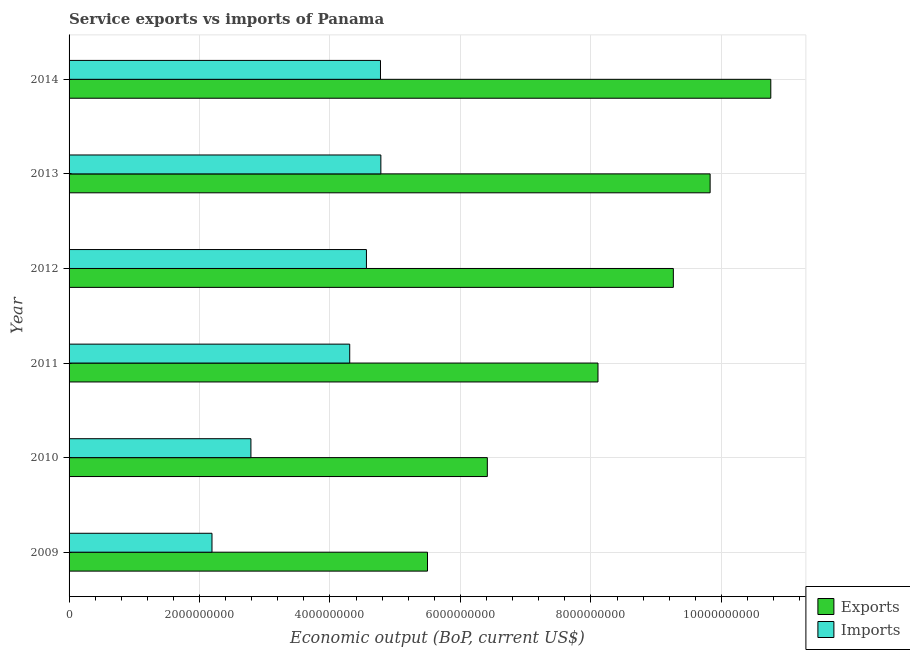Are the number of bars per tick equal to the number of legend labels?
Provide a short and direct response. Yes. Are the number of bars on each tick of the Y-axis equal?
Your response must be concise. Yes. How many bars are there on the 3rd tick from the top?
Your response must be concise. 2. How many bars are there on the 4th tick from the bottom?
Make the answer very short. 2. What is the amount of service exports in 2013?
Your answer should be very brief. 9.83e+09. Across all years, what is the maximum amount of service imports?
Give a very brief answer. 4.78e+09. Across all years, what is the minimum amount of service imports?
Make the answer very short. 2.19e+09. In which year was the amount of service exports minimum?
Make the answer very short. 2009. What is the total amount of service imports in the graph?
Give a very brief answer. 2.34e+1. What is the difference between the amount of service imports in 2011 and that in 2012?
Provide a short and direct response. -2.56e+08. What is the difference between the amount of service imports in 2014 and the amount of service exports in 2013?
Offer a terse response. -5.05e+09. What is the average amount of service imports per year?
Provide a succinct answer. 3.90e+09. In the year 2012, what is the difference between the amount of service imports and amount of service exports?
Give a very brief answer. -4.70e+09. In how many years, is the amount of service exports greater than 4800000000 US$?
Offer a terse response. 6. What is the ratio of the amount of service exports in 2010 to that in 2014?
Ensure brevity in your answer.  0.6. Is the difference between the amount of service imports in 2009 and 2010 greater than the difference between the amount of service exports in 2009 and 2010?
Give a very brief answer. Yes. What is the difference between the highest and the second highest amount of service exports?
Keep it short and to the point. 9.30e+08. What is the difference between the highest and the lowest amount of service exports?
Your answer should be compact. 5.26e+09. Is the sum of the amount of service exports in 2013 and 2014 greater than the maximum amount of service imports across all years?
Make the answer very short. Yes. What does the 2nd bar from the top in 2011 represents?
Make the answer very short. Exports. What does the 2nd bar from the bottom in 2012 represents?
Your answer should be very brief. Imports. How many bars are there?
Offer a terse response. 12. Are all the bars in the graph horizontal?
Offer a very short reply. Yes. What is the difference between two consecutive major ticks on the X-axis?
Offer a very short reply. 2.00e+09. Are the values on the major ticks of X-axis written in scientific E-notation?
Keep it short and to the point. No. Does the graph contain any zero values?
Your answer should be very brief. No. What is the title of the graph?
Offer a terse response. Service exports vs imports of Panama. Does "Overweight" appear as one of the legend labels in the graph?
Your answer should be compact. No. What is the label or title of the X-axis?
Ensure brevity in your answer.  Economic output (BoP, current US$). What is the Economic output (BoP, current US$) of Exports in 2009?
Ensure brevity in your answer.  5.49e+09. What is the Economic output (BoP, current US$) in Imports in 2009?
Your answer should be compact. 2.19e+09. What is the Economic output (BoP, current US$) of Exports in 2010?
Keep it short and to the point. 6.41e+09. What is the Economic output (BoP, current US$) in Imports in 2010?
Offer a very short reply. 2.79e+09. What is the Economic output (BoP, current US$) in Exports in 2011?
Keep it short and to the point. 8.11e+09. What is the Economic output (BoP, current US$) in Imports in 2011?
Offer a very short reply. 4.30e+09. What is the Economic output (BoP, current US$) of Exports in 2012?
Your answer should be compact. 9.26e+09. What is the Economic output (BoP, current US$) in Imports in 2012?
Offer a terse response. 4.56e+09. What is the Economic output (BoP, current US$) in Exports in 2013?
Offer a terse response. 9.83e+09. What is the Economic output (BoP, current US$) of Imports in 2013?
Offer a very short reply. 4.78e+09. What is the Economic output (BoP, current US$) in Exports in 2014?
Keep it short and to the point. 1.08e+1. What is the Economic output (BoP, current US$) in Imports in 2014?
Give a very brief answer. 4.77e+09. Across all years, what is the maximum Economic output (BoP, current US$) of Exports?
Give a very brief answer. 1.08e+1. Across all years, what is the maximum Economic output (BoP, current US$) in Imports?
Keep it short and to the point. 4.78e+09. Across all years, what is the minimum Economic output (BoP, current US$) in Exports?
Give a very brief answer. 5.49e+09. Across all years, what is the minimum Economic output (BoP, current US$) of Imports?
Keep it short and to the point. 2.19e+09. What is the total Economic output (BoP, current US$) in Exports in the graph?
Keep it short and to the point. 4.99e+1. What is the total Economic output (BoP, current US$) of Imports in the graph?
Your answer should be very brief. 2.34e+1. What is the difference between the Economic output (BoP, current US$) of Exports in 2009 and that in 2010?
Provide a short and direct response. -9.17e+08. What is the difference between the Economic output (BoP, current US$) in Imports in 2009 and that in 2010?
Provide a short and direct response. -5.97e+08. What is the difference between the Economic output (BoP, current US$) in Exports in 2009 and that in 2011?
Offer a terse response. -2.61e+09. What is the difference between the Economic output (BoP, current US$) in Imports in 2009 and that in 2011?
Provide a short and direct response. -2.11e+09. What is the difference between the Economic output (BoP, current US$) in Exports in 2009 and that in 2012?
Your answer should be compact. -3.77e+09. What is the difference between the Economic output (BoP, current US$) in Imports in 2009 and that in 2012?
Provide a succinct answer. -2.37e+09. What is the difference between the Economic output (BoP, current US$) of Exports in 2009 and that in 2013?
Make the answer very short. -4.33e+09. What is the difference between the Economic output (BoP, current US$) of Imports in 2009 and that in 2013?
Ensure brevity in your answer.  -2.59e+09. What is the difference between the Economic output (BoP, current US$) in Exports in 2009 and that in 2014?
Give a very brief answer. -5.26e+09. What is the difference between the Economic output (BoP, current US$) in Imports in 2009 and that in 2014?
Make the answer very short. -2.58e+09. What is the difference between the Economic output (BoP, current US$) of Exports in 2010 and that in 2011?
Your answer should be very brief. -1.70e+09. What is the difference between the Economic output (BoP, current US$) of Imports in 2010 and that in 2011?
Provide a short and direct response. -1.51e+09. What is the difference between the Economic output (BoP, current US$) of Exports in 2010 and that in 2012?
Provide a succinct answer. -2.85e+09. What is the difference between the Economic output (BoP, current US$) of Imports in 2010 and that in 2012?
Your response must be concise. -1.77e+09. What is the difference between the Economic output (BoP, current US$) of Exports in 2010 and that in 2013?
Provide a succinct answer. -3.42e+09. What is the difference between the Economic output (BoP, current US$) in Imports in 2010 and that in 2013?
Provide a succinct answer. -1.99e+09. What is the difference between the Economic output (BoP, current US$) in Exports in 2010 and that in 2014?
Offer a terse response. -4.35e+09. What is the difference between the Economic output (BoP, current US$) in Imports in 2010 and that in 2014?
Offer a terse response. -1.99e+09. What is the difference between the Economic output (BoP, current US$) of Exports in 2011 and that in 2012?
Give a very brief answer. -1.16e+09. What is the difference between the Economic output (BoP, current US$) of Imports in 2011 and that in 2012?
Your answer should be very brief. -2.56e+08. What is the difference between the Economic output (BoP, current US$) of Exports in 2011 and that in 2013?
Your response must be concise. -1.72e+09. What is the difference between the Economic output (BoP, current US$) of Imports in 2011 and that in 2013?
Provide a short and direct response. -4.77e+08. What is the difference between the Economic output (BoP, current US$) of Exports in 2011 and that in 2014?
Offer a terse response. -2.65e+09. What is the difference between the Economic output (BoP, current US$) in Imports in 2011 and that in 2014?
Keep it short and to the point. -4.72e+08. What is the difference between the Economic output (BoP, current US$) in Exports in 2012 and that in 2013?
Offer a very short reply. -5.64e+08. What is the difference between the Economic output (BoP, current US$) of Imports in 2012 and that in 2013?
Provide a succinct answer. -2.21e+08. What is the difference between the Economic output (BoP, current US$) of Exports in 2012 and that in 2014?
Offer a very short reply. -1.49e+09. What is the difference between the Economic output (BoP, current US$) in Imports in 2012 and that in 2014?
Offer a very short reply. -2.15e+08. What is the difference between the Economic output (BoP, current US$) of Exports in 2013 and that in 2014?
Make the answer very short. -9.30e+08. What is the difference between the Economic output (BoP, current US$) in Imports in 2013 and that in 2014?
Your answer should be very brief. 5.80e+06. What is the difference between the Economic output (BoP, current US$) of Exports in 2009 and the Economic output (BoP, current US$) of Imports in 2010?
Offer a terse response. 2.71e+09. What is the difference between the Economic output (BoP, current US$) of Exports in 2009 and the Economic output (BoP, current US$) of Imports in 2011?
Ensure brevity in your answer.  1.19e+09. What is the difference between the Economic output (BoP, current US$) in Exports in 2009 and the Economic output (BoP, current US$) in Imports in 2012?
Provide a short and direct response. 9.36e+08. What is the difference between the Economic output (BoP, current US$) of Exports in 2009 and the Economic output (BoP, current US$) of Imports in 2013?
Your answer should be compact. 7.15e+08. What is the difference between the Economic output (BoP, current US$) in Exports in 2009 and the Economic output (BoP, current US$) in Imports in 2014?
Make the answer very short. 7.21e+08. What is the difference between the Economic output (BoP, current US$) of Exports in 2010 and the Economic output (BoP, current US$) of Imports in 2011?
Your answer should be very brief. 2.11e+09. What is the difference between the Economic output (BoP, current US$) in Exports in 2010 and the Economic output (BoP, current US$) in Imports in 2012?
Keep it short and to the point. 1.85e+09. What is the difference between the Economic output (BoP, current US$) in Exports in 2010 and the Economic output (BoP, current US$) in Imports in 2013?
Keep it short and to the point. 1.63e+09. What is the difference between the Economic output (BoP, current US$) of Exports in 2010 and the Economic output (BoP, current US$) of Imports in 2014?
Provide a short and direct response. 1.64e+09. What is the difference between the Economic output (BoP, current US$) in Exports in 2011 and the Economic output (BoP, current US$) in Imports in 2012?
Your answer should be very brief. 3.55e+09. What is the difference between the Economic output (BoP, current US$) of Exports in 2011 and the Economic output (BoP, current US$) of Imports in 2013?
Ensure brevity in your answer.  3.33e+09. What is the difference between the Economic output (BoP, current US$) of Exports in 2011 and the Economic output (BoP, current US$) of Imports in 2014?
Keep it short and to the point. 3.33e+09. What is the difference between the Economic output (BoP, current US$) of Exports in 2012 and the Economic output (BoP, current US$) of Imports in 2013?
Your answer should be very brief. 4.48e+09. What is the difference between the Economic output (BoP, current US$) of Exports in 2012 and the Economic output (BoP, current US$) of Imports in 2014?
Make the answer very short. 4.49e+09. What is the difference between the Economic output (BoP, current US$) in Exports in 2013 and the Economic output (BoP, current US$) in Imports in 2014?
Your answer should be very brief. 5.05e+09. What is the average Economic output (BoP, current US$) of Exports per year?
Ensure brevity in your answer.  8.31e+09. What is the average Economic output (BoP, current US$) of Imports per year?
Make the answer very short. 3.90e+09. In the year 2009, what is the difference between the Economic output (BoP, current US$) in Exports and Economic output (BoP, current US$) in Imports?
Keep it short and to the point. 3.30e+09. In the year 2010, what is the difference between the Economic output (BoP, current US$) in Exports and Economic output (BoP, current US$) in Imports?
Provide a succinct answer. 3.62e+09. In the year 2011, what is the difference between the Economic output (BoP, current US$) in Exports and Economic output (BoP, current US$) in Imports?
Provide a short and direct response. 3.81e+09. In the year 2012, what is the difference between the Economic output (BoP, current US$) in Exports and Economic output (BoP, current US$) in Imports?
Give a very brief answer. 4.70e+09. In the year 2013, what is the difference between the Economic output (BoP, current US$) of Exports and Economic output (BoP, current US$) of Imports?
Ensure brevity in your answer.  5.05e+09. In the year 2014, what is the difference between the Economic output (BoP, current US$) in Exports and Economic output (BoP, current US$) in Imports?
Give a very brief answer. 5.98e+09. What is the ratio of the Economic output (BoP, current US$) of Exports in 2009 to that in 2010?
Your answer should be compact. 0.86. What is the ratio of the Economic output (BoP, current US$) of Imports in 2009 to that in 2010?
Keep it short and to the point. 0.79. What is the ratio of the Economic output (BoP, current US$) of Exports in 2009 to that in 2011?
Your answer should be very brief. 0.68. What is the ratio of the Economic output (BoP, current US$) of Imports in 2009 to that in 2011?
Provide a succinct answer. 0.51. What is the ratio of the Economic output (BoP, current US$) of Exports in 2009 to that in 2012?
Make the answer very short. 0.59. What is the ratio of the Economic output (BoP, current US$) in Imports in 2009 to that in 2012?
Your response must be concise. 0.48. What is the ratio of the Economic output (BoP, current US$) in Exports in 2009 to that in 2013?
Offer a terse response. 0.56. What is the ratio of the Economic output (BoP, current US$) of Imports in 2009 to that in 2013?
Your response must be concise. 0.46. What is the ratio of the Economic output (BoP, current US$) in Exports in 2009 to that in 2014?
Provide a succinct answer. 0.51. What is the ratio of the Economic output (BoP, current US$) in Imports in 2009 to that in 2014?
Keep it short and to the point. 0.46. What is the ratio of the Economic output (BoP, current US$) in Exports in 2010 to that in 2011?
Offer a terse response. 0.79. What is the ratio of the Economic output (BoP, current US$) in Imports in 2010 to that in 2011?
Offer a terse response. 0.65. What is the ratio of the Economic output (BoP, current US$) of Exports in 2010 to that in 2012?
Make the answer very short. 0.69. What is the ratio of the Economic output (BoP, current US$) in Imports in 2010 to that in 2012?
Provide a short and direct response. 0.61. What is the ratio of the Economic output (BoP, current US$) in Exports in 2010 to that in 2013?
Your answer should be very brief. 0.65. What is the ratio of the Economic output (BoP, current US$) in Imports in 2010 to that in 2013?
Ensure brevity in your answer.  0.58. What is the ratio of the Economic output (BoP, current US$) of Exports in 2010 to that in 2014?
Your answer should be compact. 0.6. What is the ratio of the Economic output (BoP, current US$) in Imports in 2010 to that in 2014?
Your answer should be very brief. 0.58. What is the ratio of the Economic output (BoP, current US$) of Exports in 2011 to that in 2012?
Your response must be concise. 0.88. What is the ratio of the Economic output (BoP, current US$) of Imports in 2011 to that in 2012?
Keep it short and to the point. 0.94. What is the ratio of the Economic output (BoP, current US$) of Exports in 2011 to that in 2013?
Provide a short and direct response. 0.83. What is the ratio of the Economic output (BoP, current US$) in Imports in 2011 to that in 2013?
Offer a very short reply. 0.9. What is the ratio of the Economic output (BoP, current US$) of Exports in 2011 to that in 2014?
Your answer should be compact. 0.75. What is the ratio of the Economic output (BoP, current US$) in Imports in 2011 to that in 2014?
Give a very brief answer. 0.9. What is the ratio of the Economic output (BoP, current US$) in Exports in 2012 to that in 2013?
Provide a short and direct response. 0.94. What is the ratio of the Economic output (BoP, current US$) of Imports in 2012 to that in 2013?
Your answer should be compact. 0.95. What is the ratio of the Economic output (BoP, current US$) in Exports in 2012 to that in 2014?
Your response must be concise. 0.86. What is the ratio of the Economic output (BoP, current US$) in Imports in 2012 to that in 2014?
Offer a terse response. 0.95. What is the ratio of the Economic output (BoP, current US$) of Exports in 2013 to that in 2014?
Offer a very short reply. 0.91. What is the difference between the highest and the second highest Economic output (BoP, current US$) in Exports?
Make the answer very short. 9.30e+08. What is the difference between the highest and the second highest Economic output (BoP, current US$) of Imports?
Your answer should be compact. 5.80e+06. What is the difference between the highest and the lowest Economic output (BoP, current US$) in Exports?
Offer a very short reply. 5.26e+09. What is the difference between the highest and the lowest Economic output (BoP, current US$) of Imports?
Ensure brevity in your answer.  2.59e+09. 